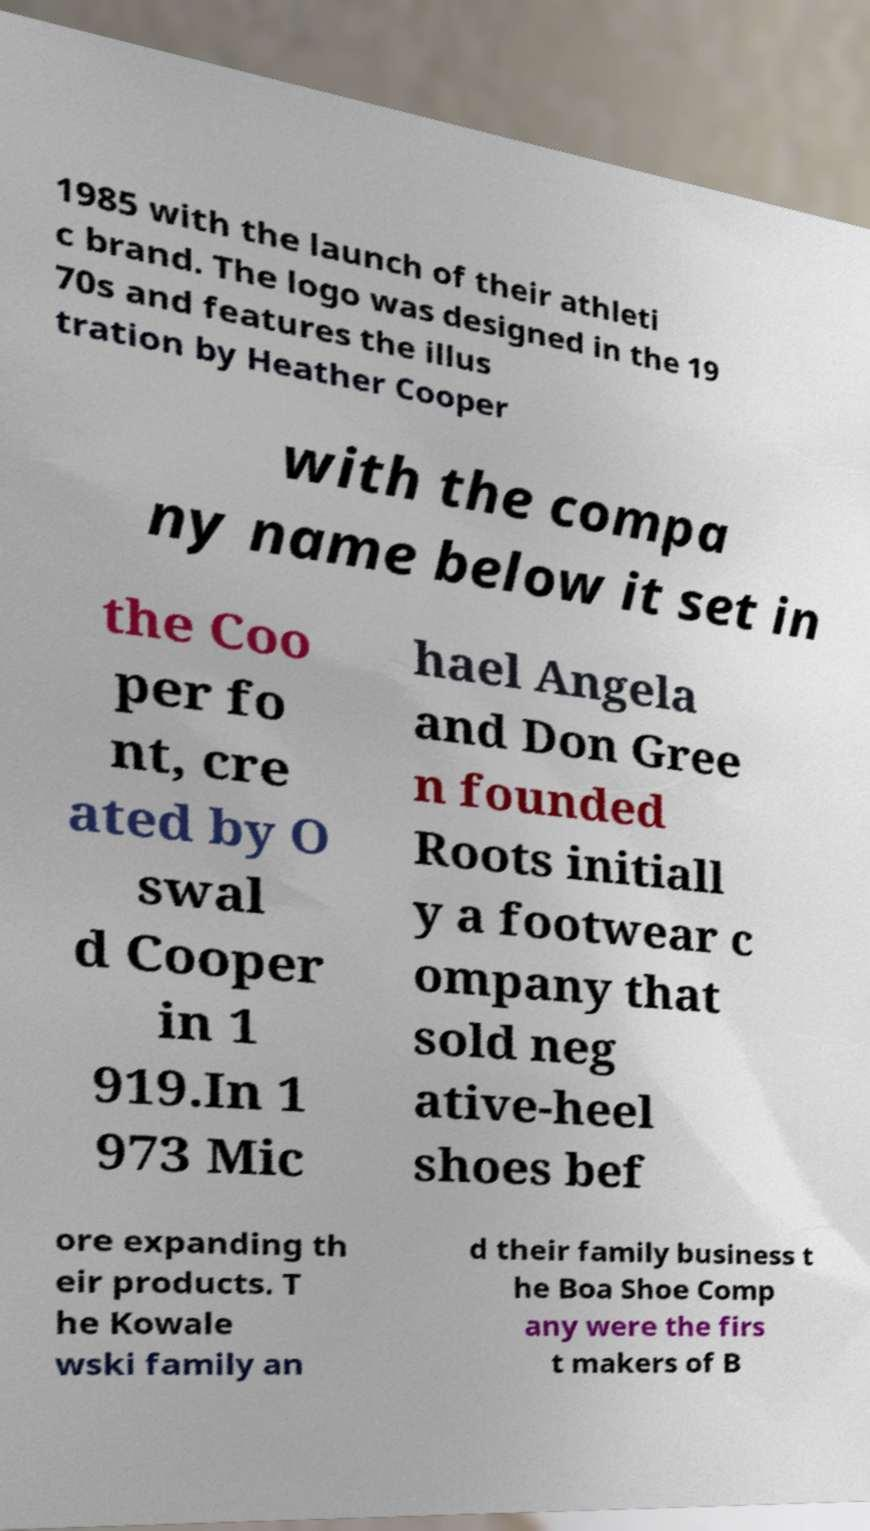Could you extract and type out the text from this image? 1985 with the launch of their athleti c brand. The logo was designed in the 19 70s and features the illus tration by Heather Cooper with the compa ny name below it set in the Coo per fo nt, cre ated by O swal d Cooper in 1 919.In 1 973 Mic hael Angela and Don Gree n founded Roots initiall y a footwear c ompany that sold neg ative-heel shoes bef ore expanding th eir products. T he Kowale wski family an d their family business t he Boa Shoe Comp any were the firs t makers of B 